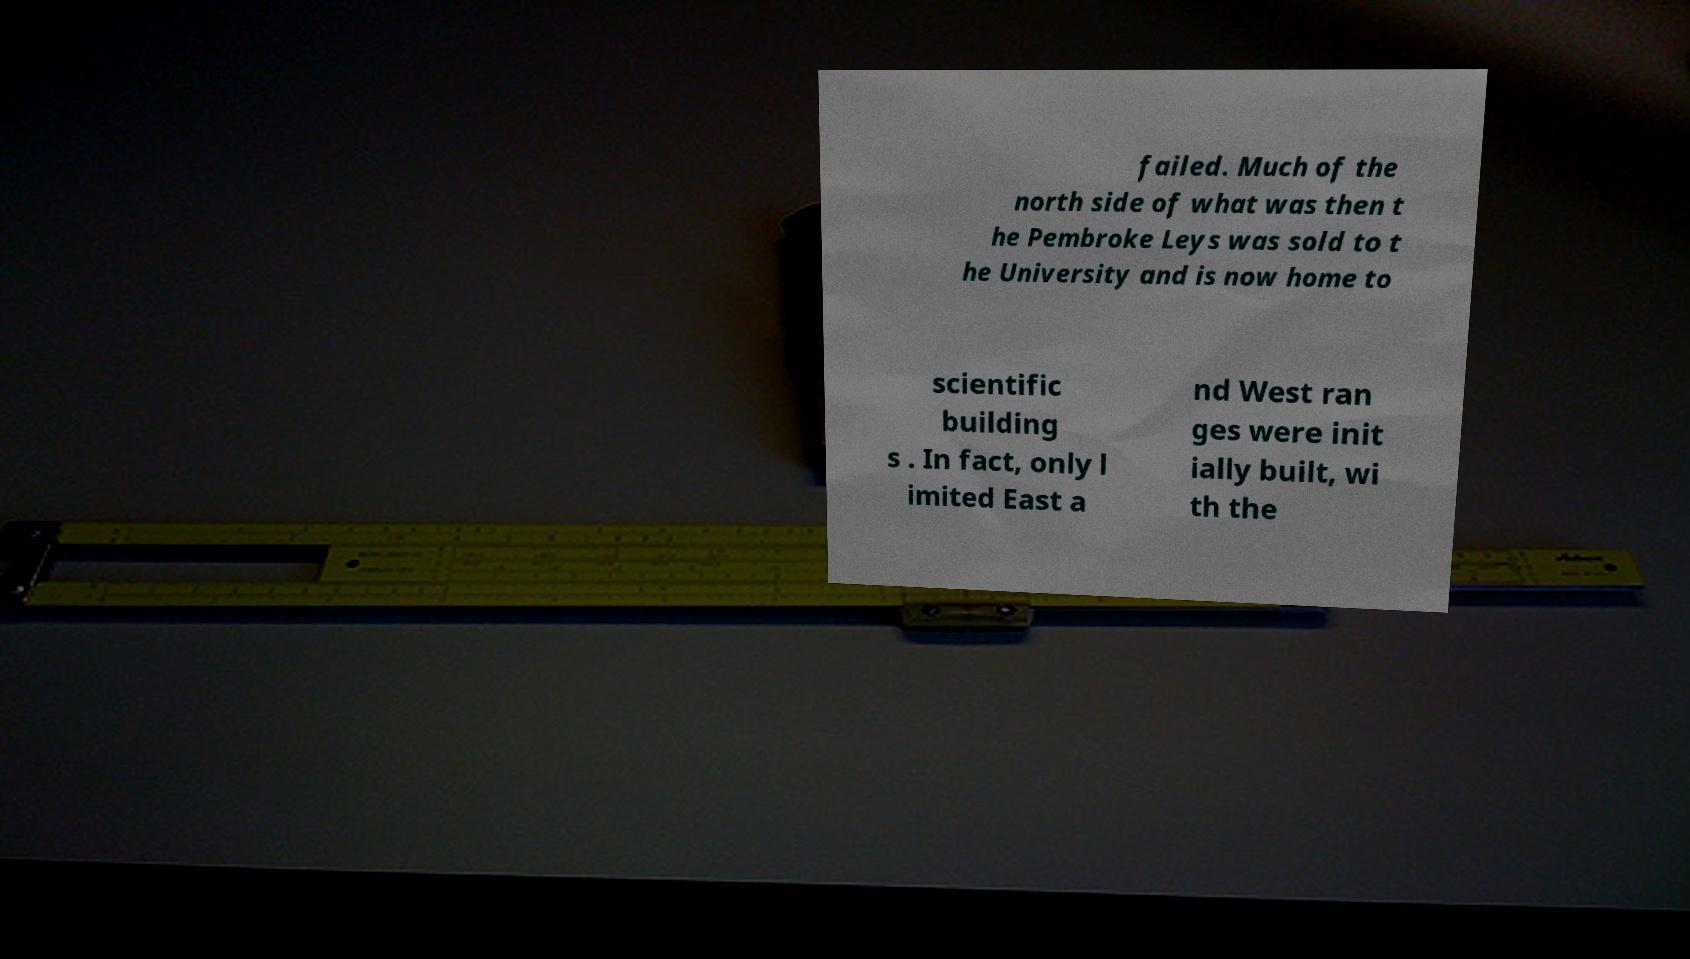For documentation purposes, I need the text within this image transcribed. Could you provide that? failed. Much of the north side of what was then t he Pembroke Leys was sold to t he University and is now home to scientific building s . In fact, only l imited East a nd West ran ges were init ially built, wi th the 